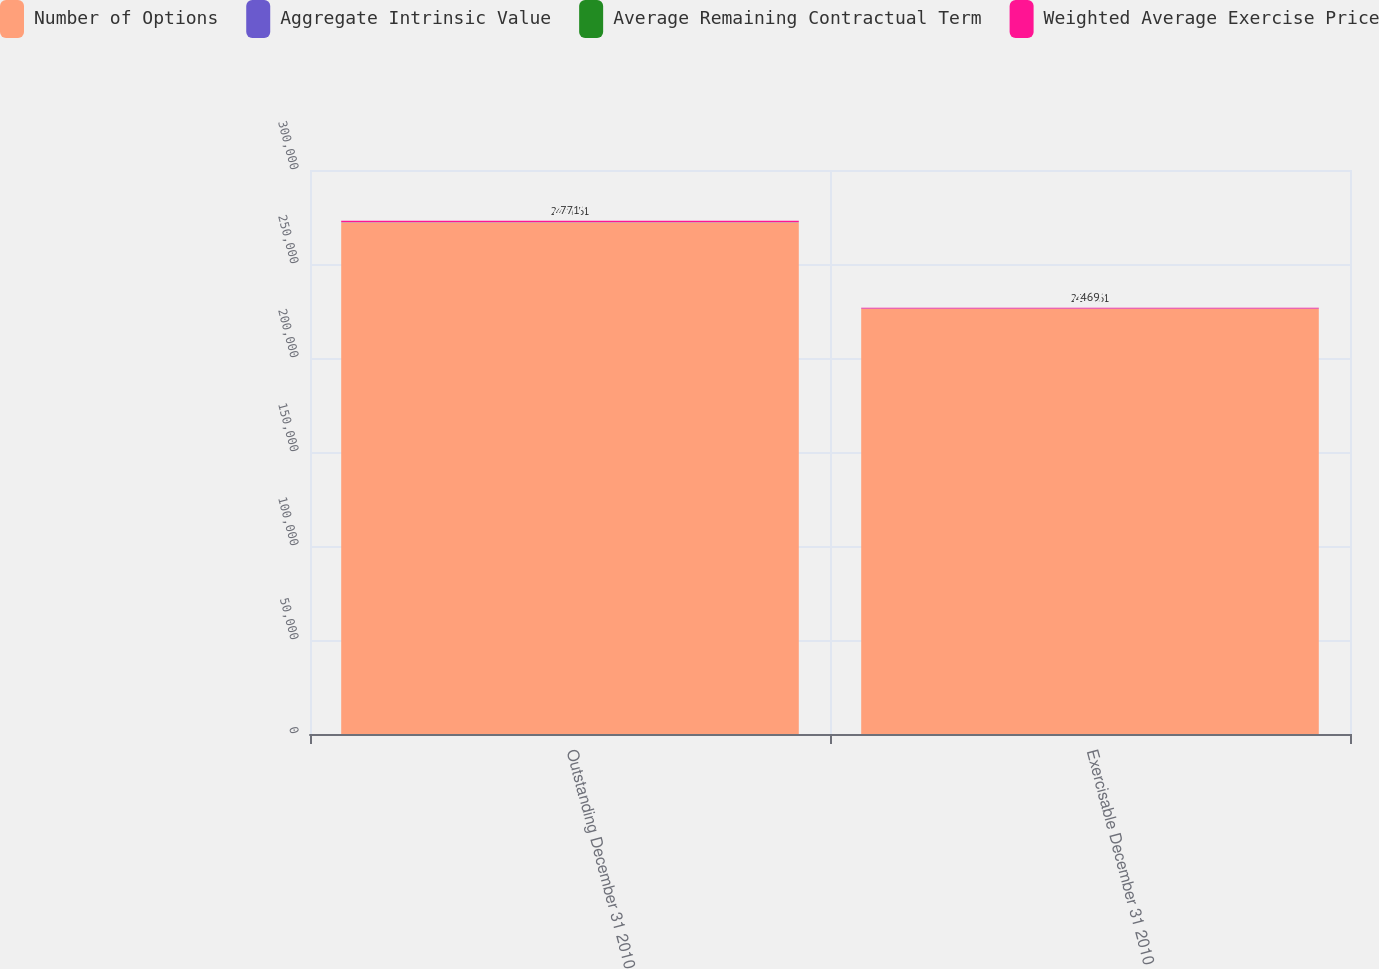Convert chart to OTSL. <chart><loc_0><loc_0><loc_500><loc_500><stacked_bar_chart><ecel><fcel>Outstanding December 31 2010<fcel>Exercisable December 31 2010<nl><fcel>Number of Options<fcel>272241<fcel>226231<nl><fcel>Aggregate Intrinsic Value<fcel>42.26<fcel>44.56<nl><fcel>Average Remaining Contractual Term<fcel>4.47<fcel>3.83<nl><fcel>Weighted Average Exercise Price<fcel>771<fcel>469<nl></chart> 